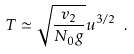<formula> <loc_0><loc_0><loc_500><loc_500>T \simeq \sqrt { \frac { v _ { 2 } } { N _ { 0 } g } } u ^ { 3 / 2 } \ .</formula> 